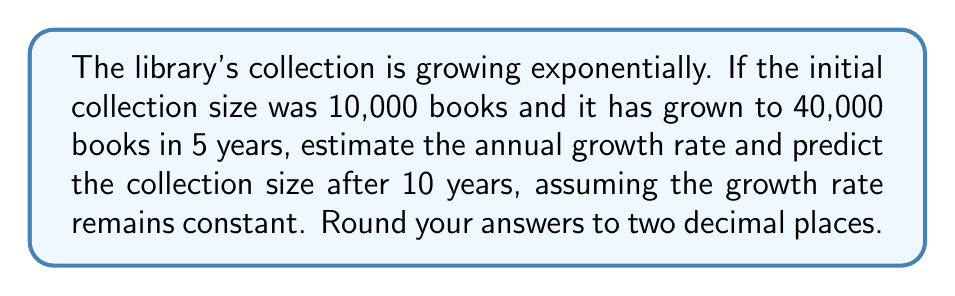Could you help me with this problem? To solve this problem, we'll use the exponential growth formula:

$$A = P(1 + r)^t$$

Where:
$A$ = Final amount
$P$ = Initial principal balance
$r$ = Annual growth rate (in decimal form)
$t$ = Time period (in years)

Step 1: Set up the equation using the given information.
$$40,000 = 10,000(1 + r)^5$$

Step 2: Solve for $r$.
$$4 = (1 + r)^5$$
$$\sqrt[5]{4} = 1 + r$$
$$r = \sqrt[5]{4} - 1$$
$$r \approx 0.3195 \text{ or } 31.95\%$$

Step 3: Predict the collection size after 10 years using the calculated growth rate.
$$A = 10,000(1 + 0.3195)^{10}$$
$$A \approx 160,000.39$$

Rounding to the nearest whole number (as we can't have partial books), the collection size after 10 years would be 160,000 books.
Answer: Annual growth rate: 31.95%, Collection size after 10 years: 160,000 books 